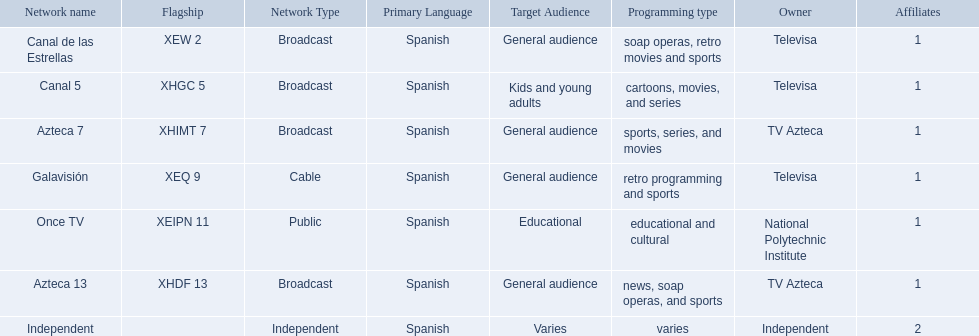What stations show sports? Soap operas, retro movies and sports, retro programming and sports, news, soap operas, and sports. What of these is not affiliated with televisa? Azteca 7. 